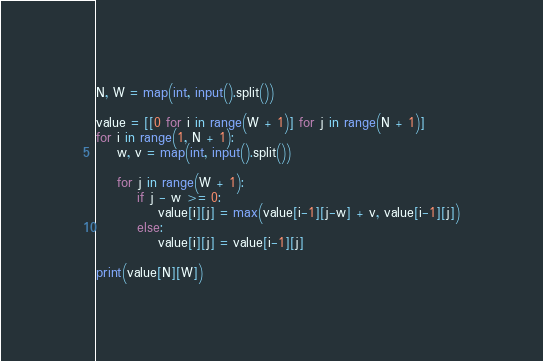<code> <loc_0><loc_0><loc_500><loc_500><_Python_>N, W = map(int, input().split())

value = [[0 for i in range(W + 1)] for j in range(N + 1)]
for i in range(1, N + 1):
    w, v = map(int, input().split())

    for j in range(W + 1):
        if j - w >= 0:
            value[i][j] = max(value[i-1][j-w] + v, value[i-1][j])
        else:
            value[i][j] = value[i-1][j]

print(value[N][W])</code> 